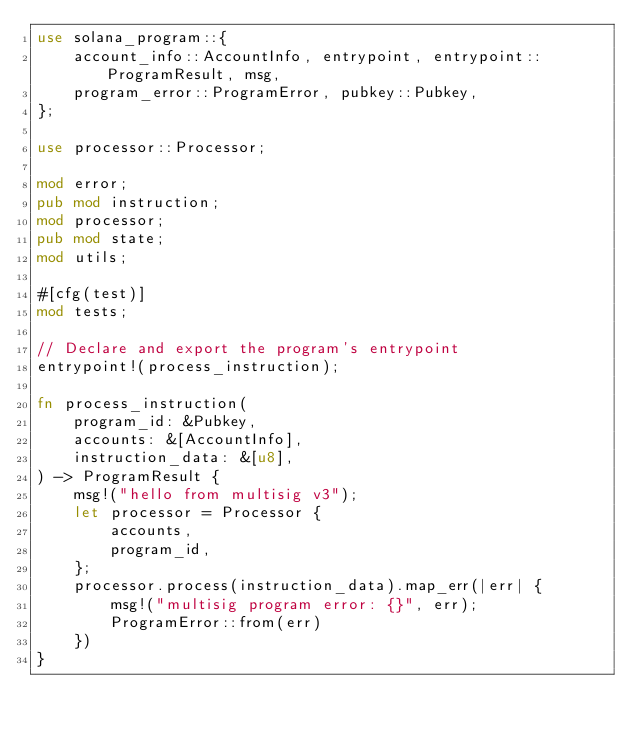<code> <loc_0><loc_0><loc_500><loc_500><_Rust_>use solana_program::{
    account_info::AccountInfo, entrypoint, entrypoint::ProgramResult, msg,
    program_error::ProgramError, pubkey::Pubkey,
};

use processor::Processor;

mod error;
pub mod instruction;
mod processor;
pub mod state;
mod utils;

#[cfg(test)]
mod tests;

// Declare and export the program's entrypoint
entrypoint!(process_instruction);

fn process_instruction(
    program_id: &Pubkey,
    accounts: &[AccountInfo],
    instruction_data: &[u8],
) -> ProgramResult {
    msg!("hello from multisig v3");
    let processor = Processor {
        accounts,
        program_id,
    };
    processor.process(instruction_data).map_err(|err| {
        msg!("multisig program error: {}", err);
        ProgramError::from(err)
    })
}
</code> 